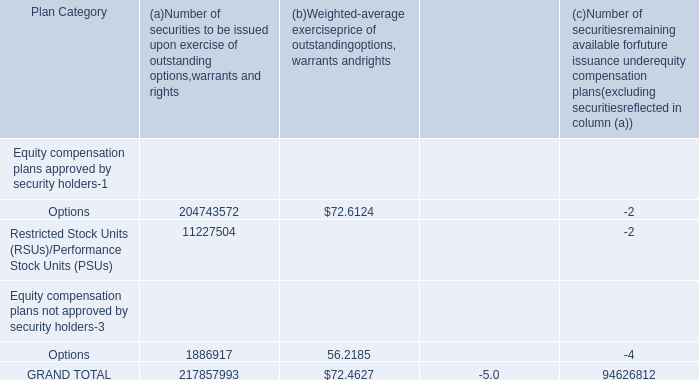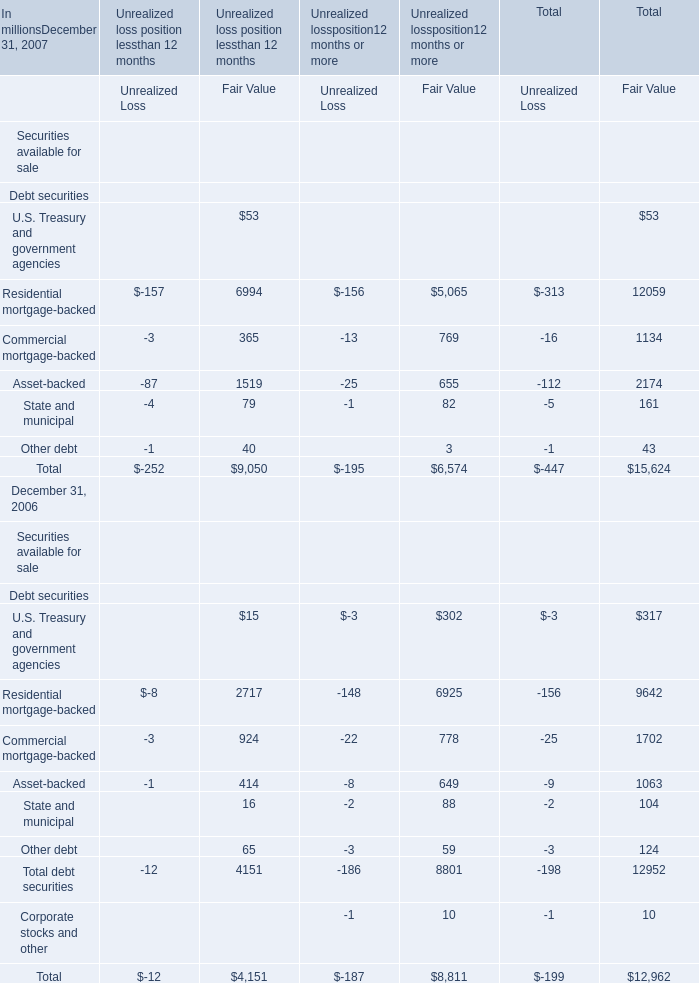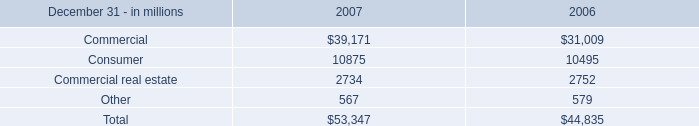consumer home equity lines of credit accounted for 80% ( 80 % ) of consumer unfunded credit commitments . what is this amount in 2007 in millions of dollars? 
Computations: (80% * 10875)
Answer: 8700.0. 